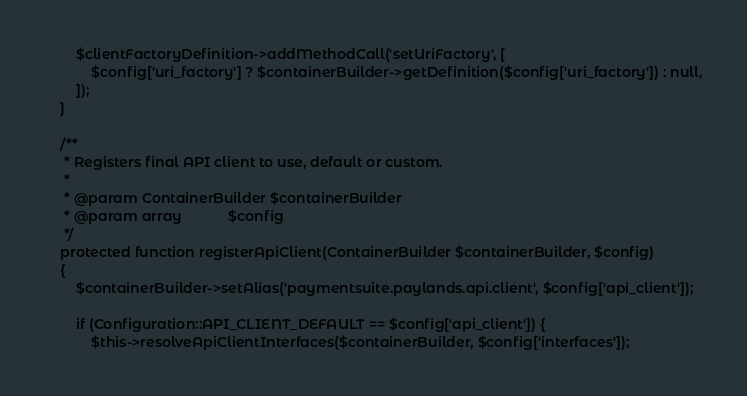Convert code to text. <code><loc_0><loc_0><loc_500><loc_500><_PHP_>        $clientFactoryDefinition->addMethodCall('setUriFactory', [
            $config['uri_factory'] ? $containerBuilder->getDefinition($config['uri_factory']) : null,
        ]);
    }

    /**
     * Registers final API client to use, default or custom.
     *
     * @param ContainerBuilder $containerBuilder
     * @param array            $config
     */
    protected function registerApiClient(ContainerBuilder $containerBuilder, $config)
    {
        $containerBuilder->setAlias('paymentsuite.paylands.api.client', $config['api_client']);

        if (Configuration::API_CLIENT_DEFAULT == $config['api_client']) {
            $this->resolveApiClientInterfaces($containerBuilder, $config['interfaces']);
</code> 